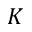Convert formula to latex. <formula><loc_0><loc_0><loc_500><loc_500>K</formula> 